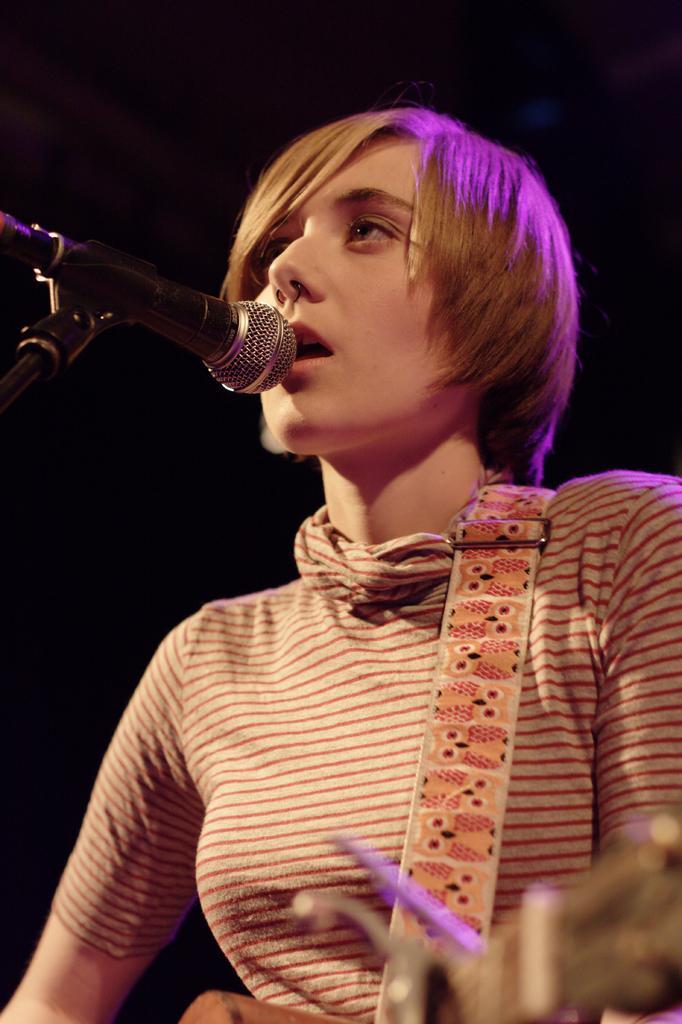How would you summarize this image in a sentence or two? This image consists of a woman singing and playing a guitar. The background is the too dark. 